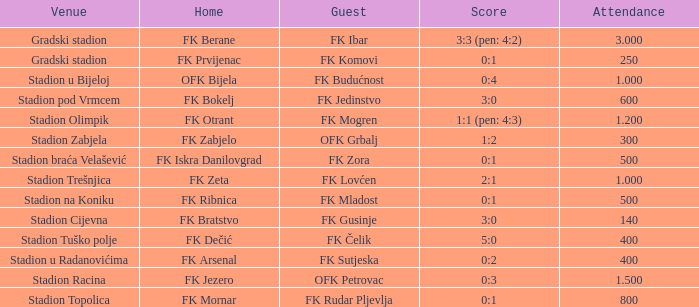What was the attendance of the game that had an away team of FK Mogren? 1.2. 